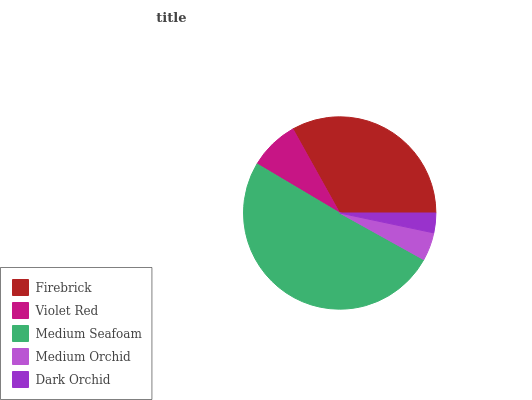Is Dark Orchid the minimum?
Answer yes or no. Yes. Is Medium Seafoam the maximum?
Answer yes or no. Yes. Is Violet Red the minimum?
Answer yes or no. No. Is Violet Red the maximum?
Answer yes or no. No. Is Firebrick greater than Violet Red?
Answer yes or no. Yes. Is Violet Red less than Firebrick?
Answer yes or no. Yes. Is Violet Red greater than Firebrick?
Answer yes or no. No. Is Firebrick less than Violet Red?
Answer yes or no. No. Is Violet Red the high median?
Answer yes or no. Yes. Is Violet Red the low median?
Answer yes or no. Yes. Is Dark Orchid the high median?
Answer yes or no. No. Is Firebrick the low median?
Answer yes or no. No. 